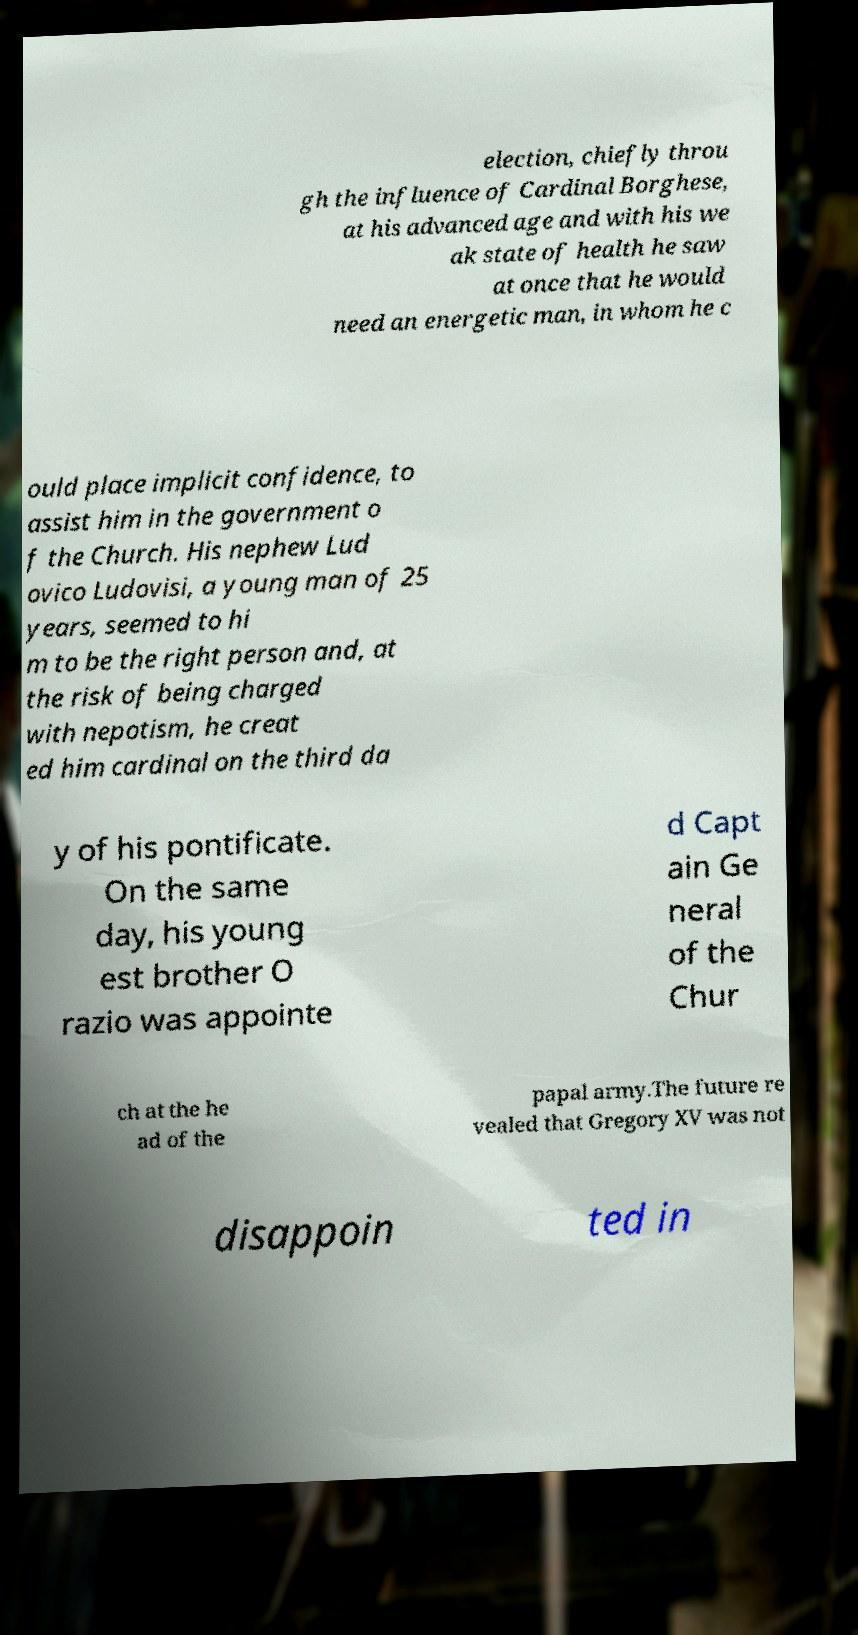I need the written content from this picture converted into text. Can you do that? election, chiefly throu gh the influence of Cardinal Borghese, at his advanced age and with his we ak state of health he saw at once that he would need an energetic man, in whom he c ould place implicit confidence, to assist him in the government o f the Church. His nephew Lud ovico Ludovisi, a young man of 25 years, seemed to hi m to be the right person and, at the risk of being charged with nepotism, he creat ed him cardinal on the third da y of his pontificate. On the same day, his young est brother O razio was appointe d Capt ain Ge neral of the Chur ch at the he ad of the papal army.The future re vealed that Gregory XV was not disappoin ted in 